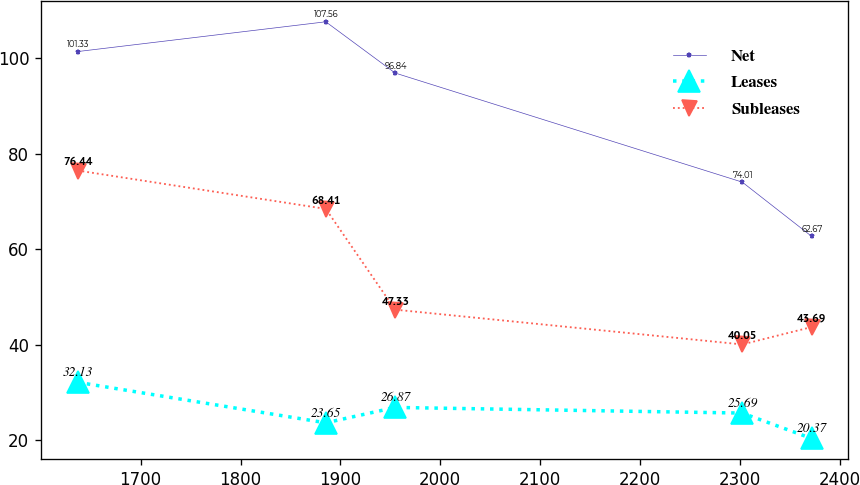<chart> <loc_0><loc_0><loc_500><loc_500><line_chart><ecel><fcel>Net<fcel>Leases<fcel>Subleases<nl><fcel>1636.91<fcel>101.33<fcel>32.13<fcel>76.44<nl><fcel>1885.36<fcel>107.56<fcel>23.65<fcel>68.41<nl><fcel>1954.78<fcel>96.84<fcel>26.87<fcel>47.33<nl><fcel>2302.34<fcel>74.01<fcel>25.69<fcel>40.05<nl><fcel>2371.76<fcel>62.67<fcel>20.37<fcel>43.69<nl></chart> 